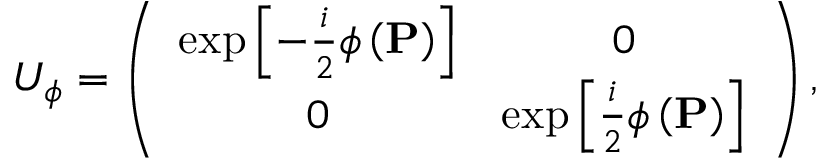<formula> <loc_0><loc_0><loc_500><loc_500>U _ { \phi } = \left ( \begin{array} { c c } { \exp \left [ - \frac { i } { 2 } \phi \left ( P \right ) \right ] } & { 0 } \\ { 0 } & { \exp \left [ \frac { i } { 2 } \phi \left ( P \right ) \right ] } \end{array} \right ) ,</formula> 